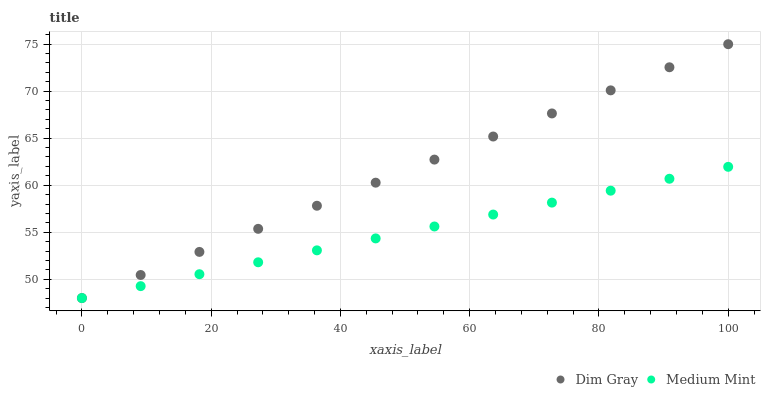Does Medium Mint have the minimum area under the curve?
Answer yes or no. Yes. Does Dim Gray have the maximum area under the curve?
Answer yes or no. Yes. Does Dim Gray have the minimum area under the curve?
Answer yes or no. No. Is Medium Mint the smoothest?
Answer yes or no. Yes. Is Dim Gray the roughest?
Answer yes or no. Yes. Is Dim Gray the smoothest?
Answer yes or no. No. Does Medium Mint have the lowest value?
Answer yes or no. Yes. Does Dim Gray have the highest value?
Answer yes or no. Yes. Does Dim Gray intersect Medium Mint?
Answer yes or no. Yes. Is Dim Gray less than Medium Mint?
Answer yes or no. No. Is Dim Gray greater than Medium Mint?
Answer yes or no. No. 